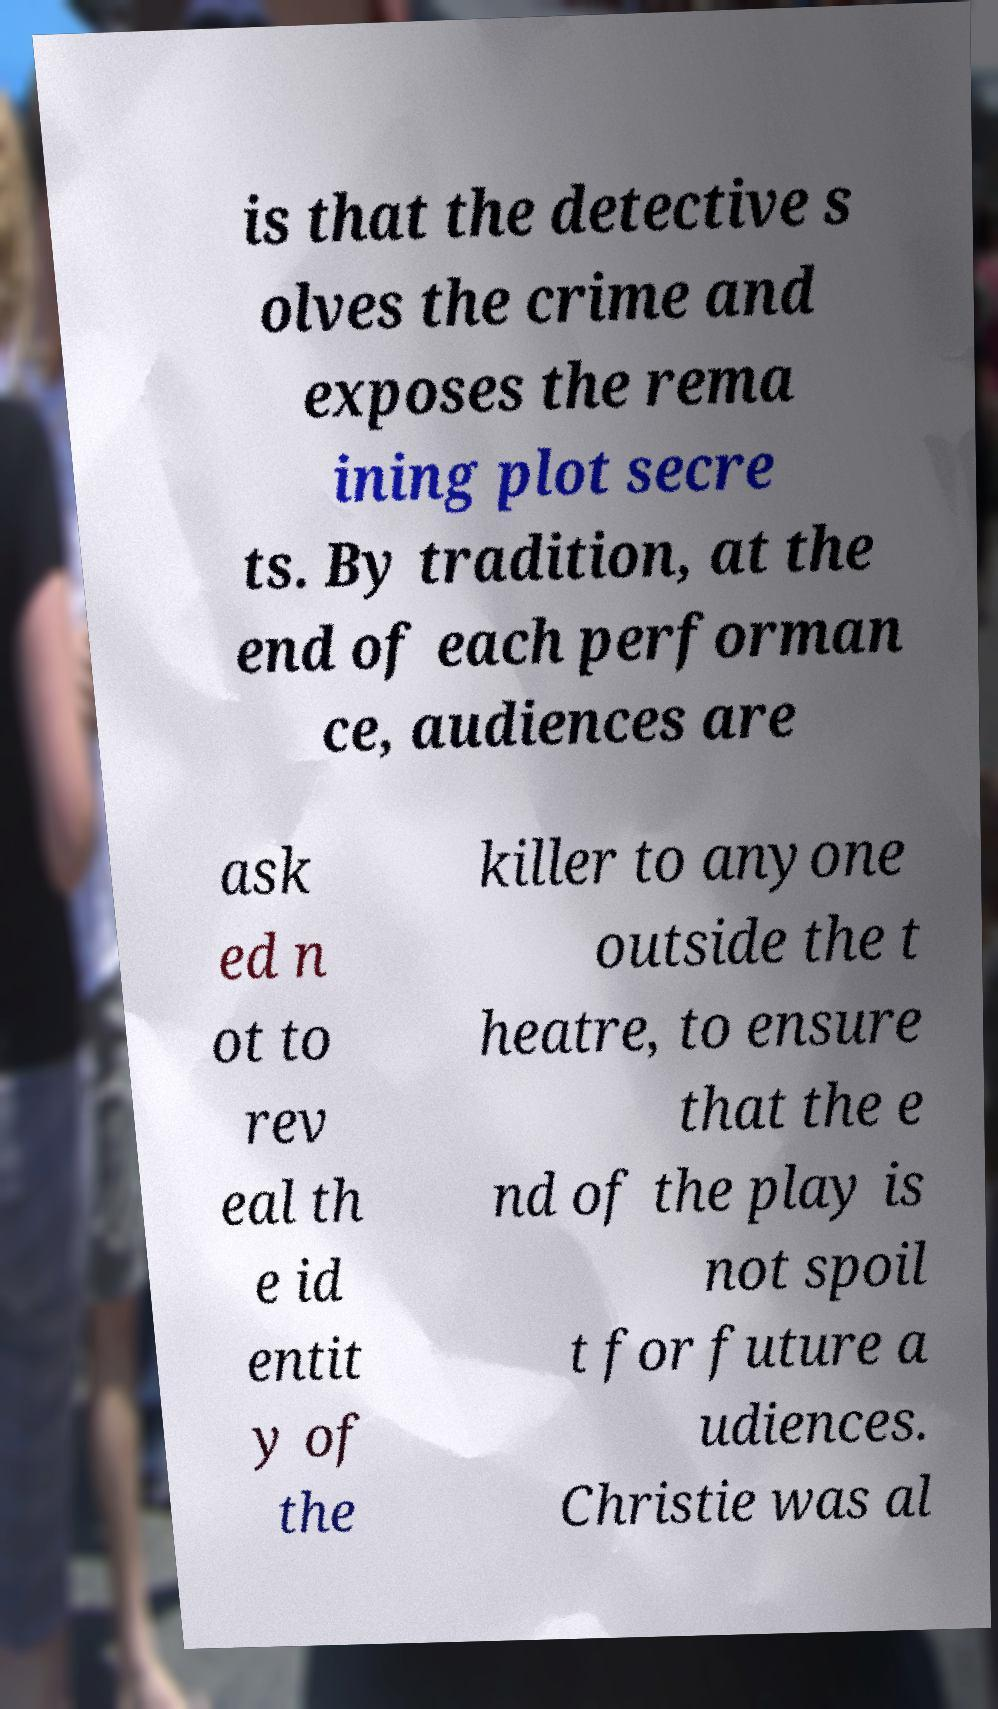Can you read and provide the text displayed in the image?This photo seems to have some interesting text. Can you extract and type it out for me? is that the detective s olves the crime and exposes the rema ining plot secre ts. By tradition, at the end of each performan ce, audiences are ask ed n ot to rev eal th e id entit y of the killer to anyone outside the t heatre, to ensure that the e nd of the play is not spoil t for future a udiences. Christie was al 